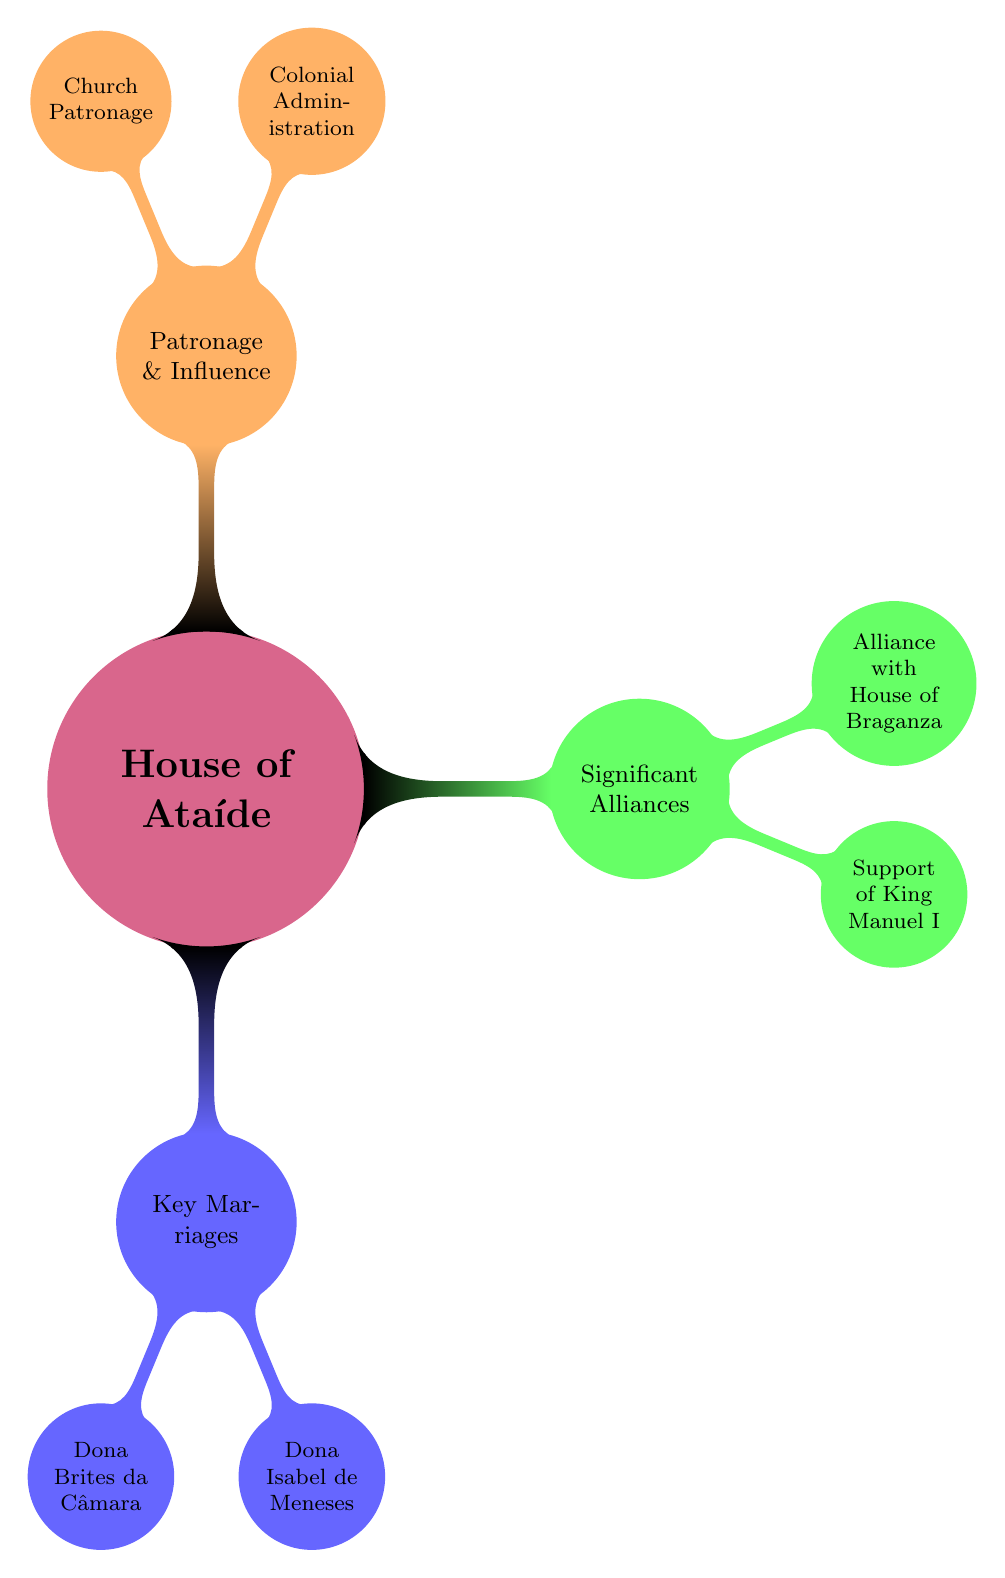What are the names of the key marriages? The diagram lists two key marriages: Dona Brites da Câmara and Dona Isabel de Meneses under the "Key Marriages" node.
Answer: Dona Brites da Câmara, Dona Isabel de Meneses Who was the spouse of Dona Brites da Câmara? According to the diagram, the spouse of Dona Brites da Câmara is Dom Fernando de Ataíde, which can be found directly under her node in the "Key Marriages" section.
Answer: Dom Fernando de Ataíde Which family did the marriage of Dona Isabel de Meneses strengthen ties with? The diagram indicates that the marriage of Dona Isabel de Meneses was significant for strengthening ties with the powerful Meneses family, as mentioned in the political significance below her node.
Answer: Meneses family How many significant alliances are shown in the diagram? By examining the "Significant Alliances" section, we can see that there are two specific alliances listed: "Support of King Manuel I" and "Alliance with the House of Braganza." Therefore, the total count is two.
Answer: 2 What position is associated with the Colonial Administration? The diagram specifies that the position related to the Colonial Administration is "Governors of Portuguese Territories in India," which is mentioned under the "Patronage & Influence" section.
Answer: Governors of Portuguese Territories in India Which duke is connected with the Alliance with the House of Braganza? The diagram clearly states that the duke involved in the Alliance with the House of Braganza is Dom Teodósio I, as listed under the "Alliance with House of Braganza" node.
Answer: Dom Teodósio I What role did Dom Álvaro de Ataíde play in the political alliances? The diagram underscores that Dom Álvaro de Ataíde was a key figure who supported King Manuel I of Portugal, enhancing the family's political influence.
Answer: Support of King Manuel I What contribution did the House of Ataíde make to the Church? The diagram notes their contribution to being major patrons of religious institutions in Portugal, reflecting their influence within the Catholic Church mentioned under "Church Patronage."
Answer: Major patrons of religious institutions in Portugal How many nodes are in the "Patronage & Influence" section? The "Patronage & Influence" section has two child nodes listed: "Colonial Administration" and "Church Patronage." Therefore, the count is two.
Answer: 2 